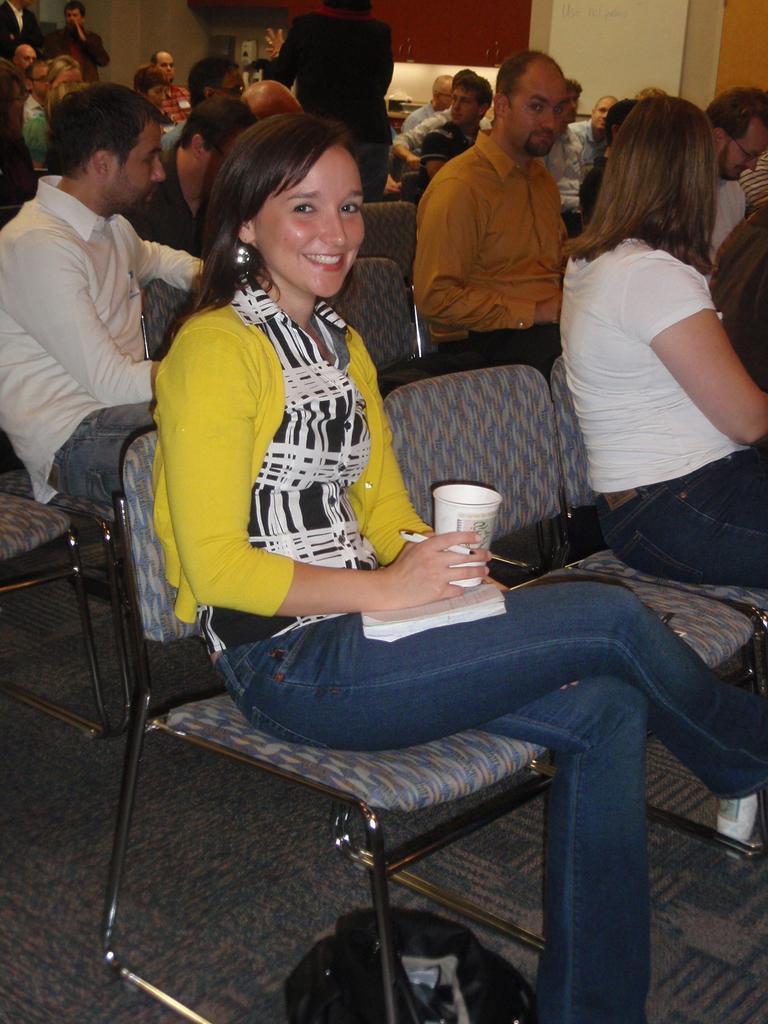Describe this image in one or two sentences. Here is the woman sitting on the chair and she is smiling and she is holding a glass in her hand, and there are group of people sitting ,and here a woman is standing. 